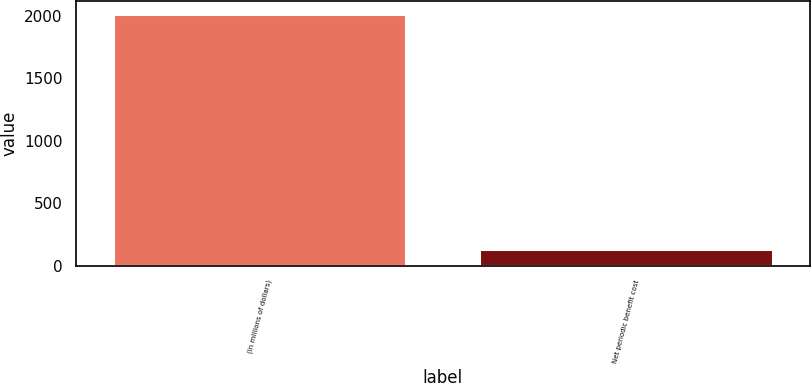Convert chart. <chart><loc_0><loc_0><loc_500><loc_500><bar_chart><fcel>(In millions of dollars)<fcel>Net periodic benefit cost<nl><fcel>2012<fcel>137<nl></chart> 